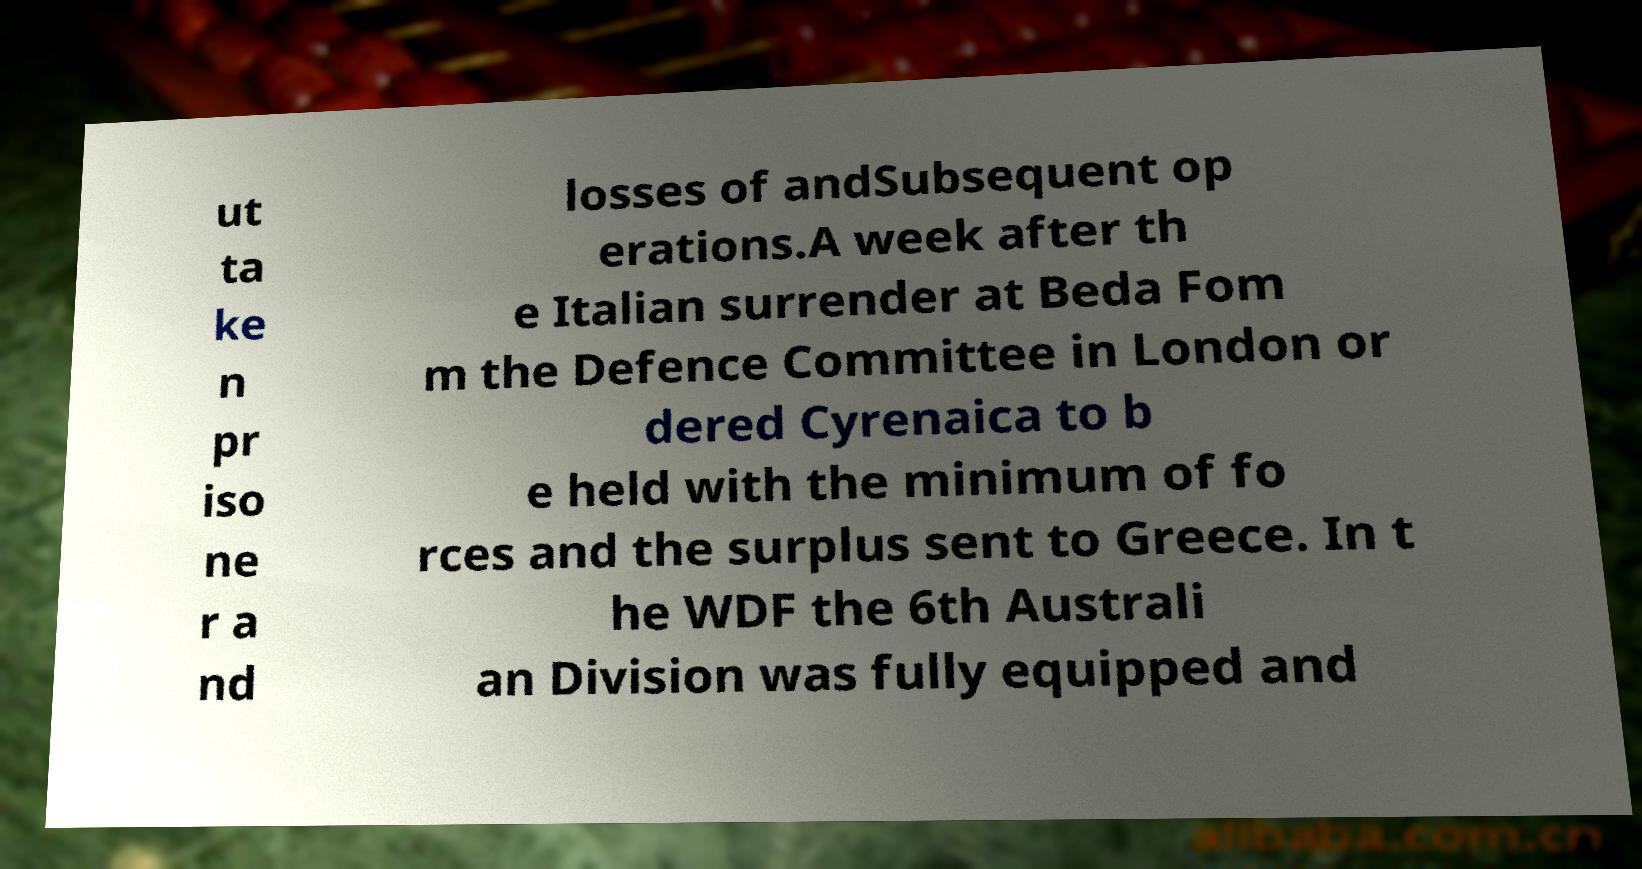Can you accurately transcribe the text from the provided image for me? ut ta ke n pr iso ne r a nd losses of andSubsequent op erations.A week after th e Italian surrender at Beda Fom m the Defence Committee in London or dered Cyrenaica to b e held with the minimum of fo rces and the surplus sent to Greece. In t he WDF the 6th Australi an Division was fully equipped and 